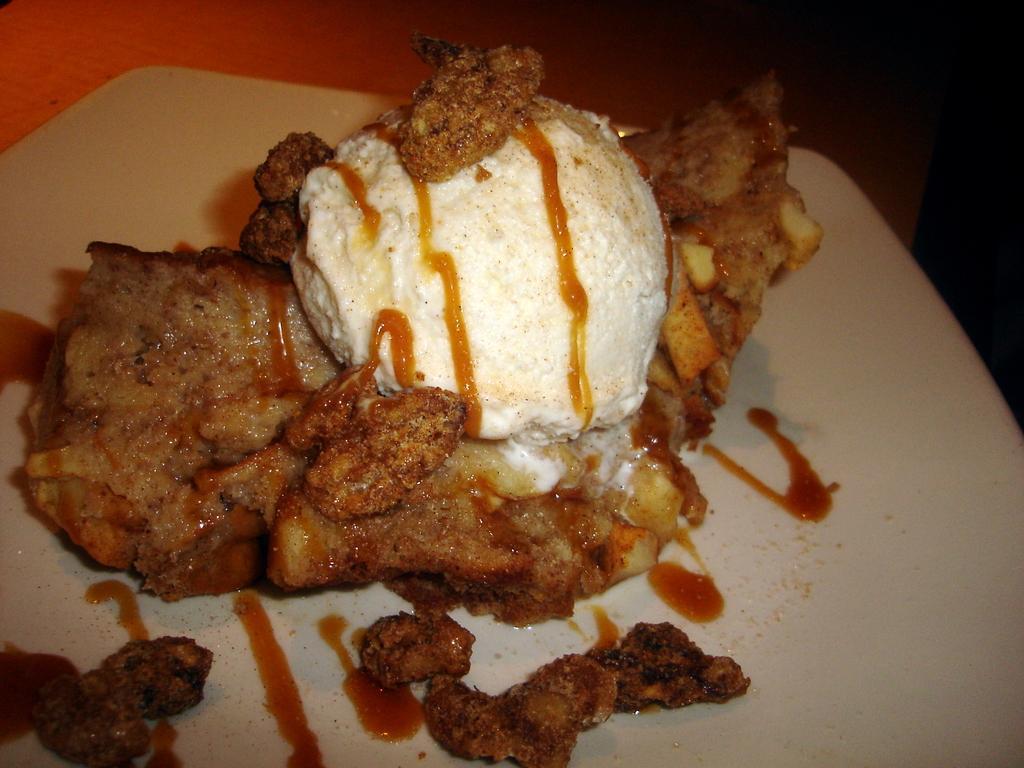In one or two sentences, can you explain what this image depicts? In this picture I can observe some food on the table. The food is in white and brown color. 